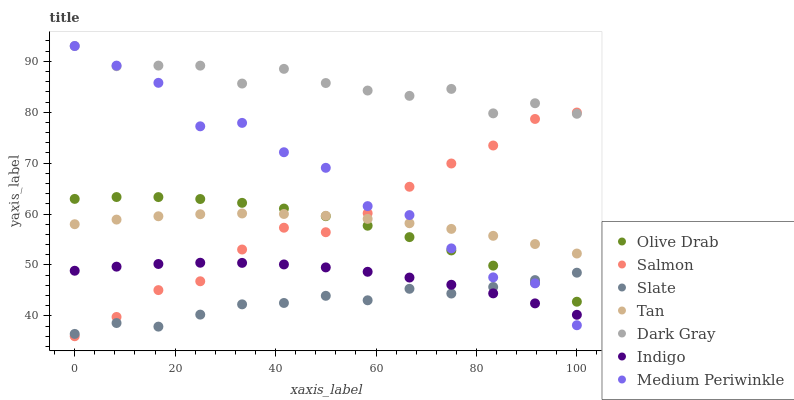Does Slate have the minimum area under the curve?
Answer yes or no. Yes. Does Dark Gray have the maximum area under the curve?
Answer yes or no. Yes. Does Medium Periwinkle have the minimum area under the curve?
Answer yes or no. No. Does Medium Periwinkle have the maximum area under the curve?
Answer yes or no. No. Is Tan the smoothest?
Answer yes or no. Yes. Is Medium Periwinkle the roughest?
Answer yes or no. Yes. Is Slate the smoothest?
Answer yes or no. No. Is Slate the roughest?
Answer yes or no. No. Does Salmon have the lowest value?
Answer yes or no. Yes. Does Medium Periwinkle have the lowest value?
Answer yes or no. No. Does Dark Gray have the highest value?
Answer yes or no. Yes. Does Slate have the highest value?
Answer yes or no. No. Is Indigo less than Olive Drab?
Answer yes or no. Yes. Is Dark Gray greater than Slate?
Answer yes or no. Yes. Does Salmon intersect Slate?
Answer yes or no. Yes. Is Salmon less than Slate?
Answer yes or no. No. Is Salmon greater than Slate?
Answer yes or no. No. Does Indigo intersect Olive Drab?
Answer yes or no. No. 